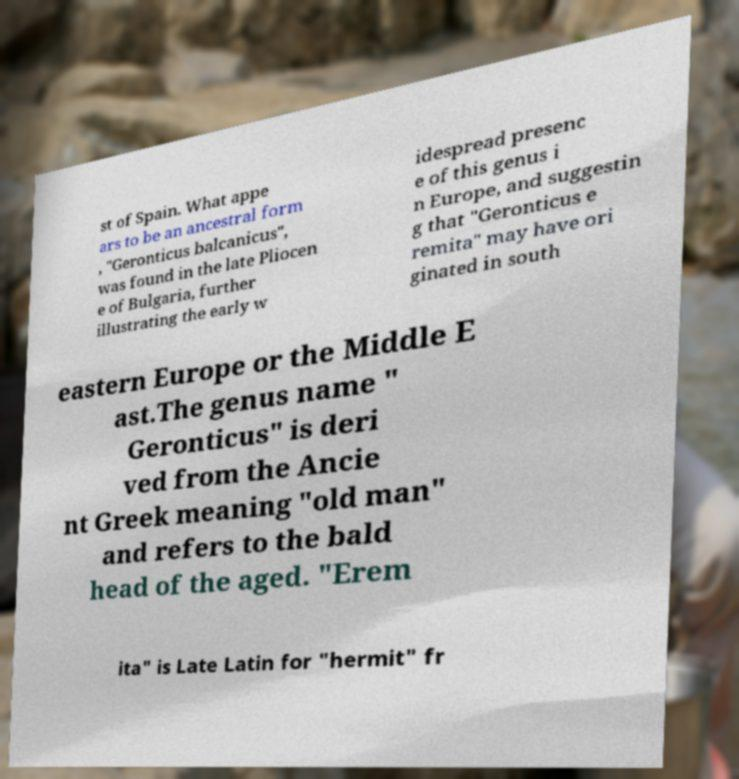Please read and relay the text visible in this image. What does it say? st of Spain. What appe ars to be an ancestral form , "Geronticus balcanicus", was found in the late Pliocen e of Bulgaria, further illustrating the early w idespread presenc e of this genus i n Europe, and suggestin g that "Geronticus e remita" may have ori ginated in south eastern Europe or the Middle E ast.The genus name " Geronticus" is deri ved from the Ancie nt Greek meaning "old man" and refers to the bald head of the aged. "Erem ita" is Late Latin for "hermit" fr 